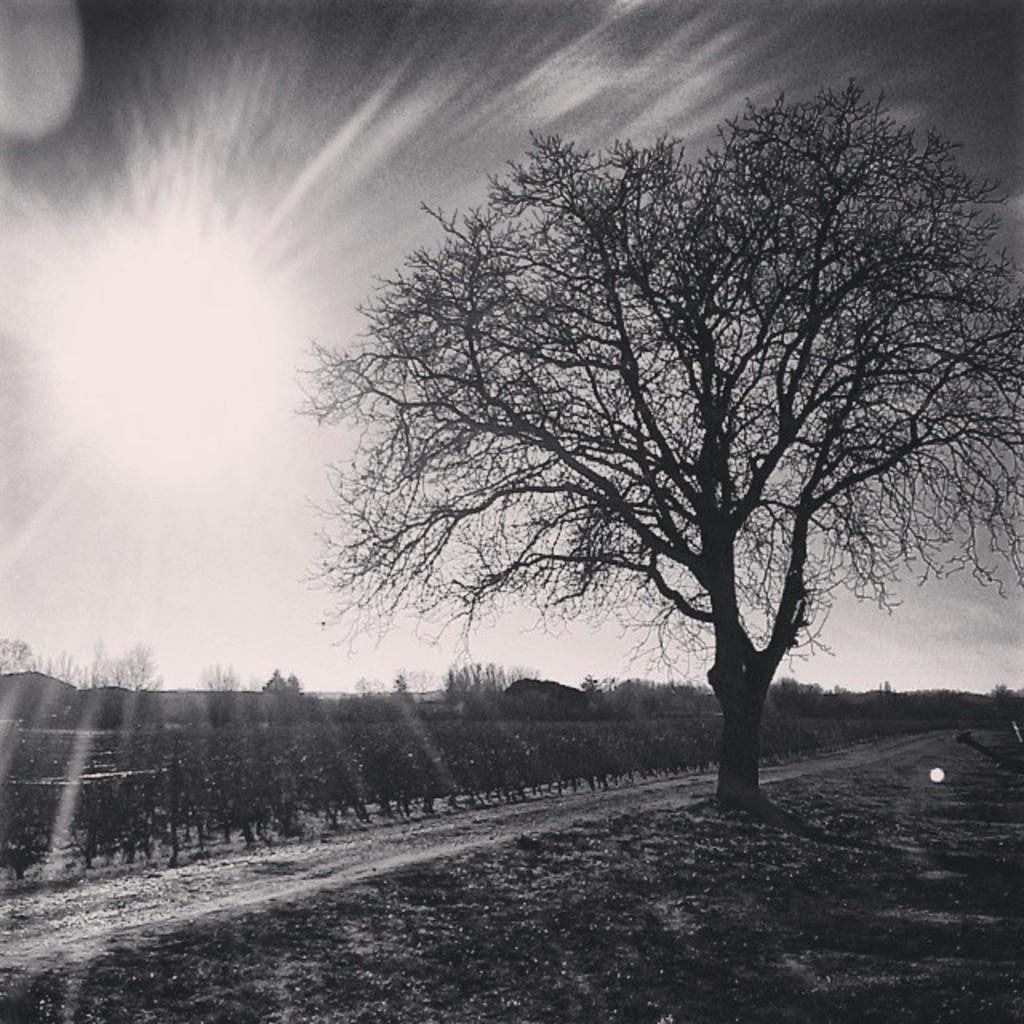What type of vegetation can be seen in the image? There are trees and plants in the image. What is visible beneath the trees and plants? The ground is visible in the image. What can be seen in the sky in the image? The sun is observable in the image. What is the weight of the plant in the image? There is no specific plant mentioned in the image, and therefore its weight cannot be determined. 